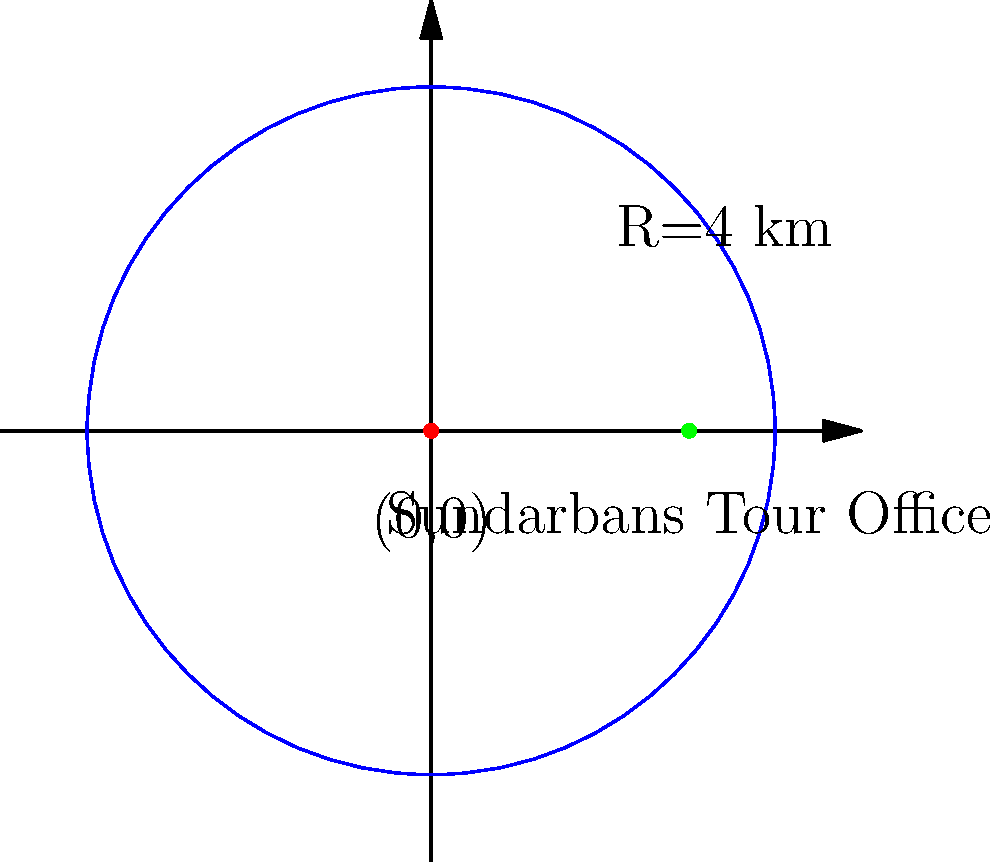As a tour guide in Khulna Division, you're working with a local tour service that operates in the Sundarbans area. The company's coverage area can be represented by a circle with its center at the origin (0,0) and a radius of 4 km. The tour office is located at the point (3,0). Find the equation of the circle representing the coverage area and determine if the tour office lies within this area. Let's approach this step-by-step:

1) The general equation of a circle is $$(x-h)^2 + (y-k)^2 = r^2$$
   where (h,k) is the center and r is the radius.

2) In this case, the center is at (0,0) and the radius is 4 km.
   So, h = 0, k = 0, and r = 4.

3) Substituting these values into the general equation:
   $$(x-0)^2 + (y-0)^2 = 4^2$$

4) Simplifying:
   $$x^2 + y^2 = 16$$

5) This is the equation of the circle representing the coverage area.

6) To determine if the tour office (3,0) lies within this area, we substitute its coordinates into the equation:
   $$(3)^2 + (0)^2 = 9 + 0 = 9$$

7) Since 9 < 16, the point (3,0) satisfies the inequality $x^2 + y^2 < 16$.

Therefore, the tour office lies within the coverage area.
Answer: Equation: $x^2 + y^2 = 16$; Office is inside the coverage area. 